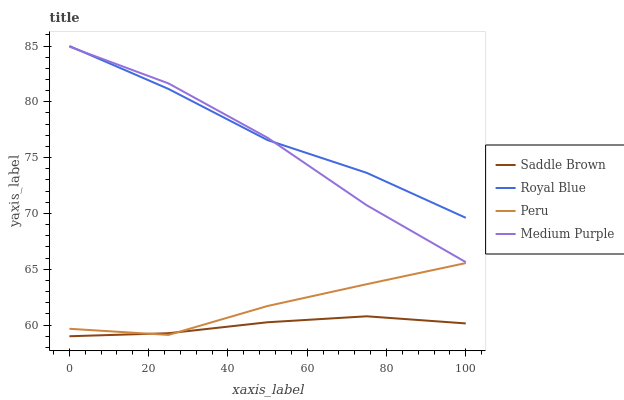Does Saddle Brown have the minimum area under the curve?
Answer yes or no. Yes. Does Royal Blue have the maximum area under the curve?
Answer yes or no. Yes. Does Royal Blue have the minimum area under the curve?
Answer yes or no. No. Does Saddle Brown have the maximum area under the curve?
Answer yes or no. No. Is Saddle Brown the smoothest?
Answer yes or no. Yes. Is Peru the roughest?
Answer yes or no. Yes. Is Royal Blue the smoothest?
Answer yes or no. No. Is Royal Blue the roughest?
Answer yes or no. No. Does Royal Blue have the lowest value?
Answer yes or no. No. Does Royal Blue have the highest value?
Answer yes or no. Yes. Does Saddle Brown have the highest value?
Answer yes or no. No. Is Saddle Brown less than Medium Purple?
Answer yes or no. Yes. Is Royal Blue greater than Saddle Brown?
Answer yes or no. Yes. Does Medium Purple intersect Royal Blue?
Answer yes or no. Yes. Is Medium Purple less than Royal Blue?
Answer yes or no. No. Is Medium Purple greater than Royal Blue?
Answer yes or no. No. Does Saddle Brown intersect Medium Purple?
Answer yes or no. No. 